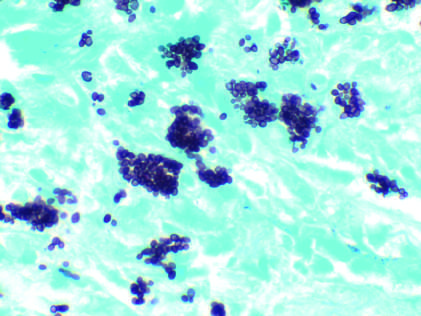do histoplasma capsulatum yeast forms fill phagocytes in a lymph node of a patient with disseminated histoplasmosis silver stain?
Answer the question using a single word or phrase. Yes 